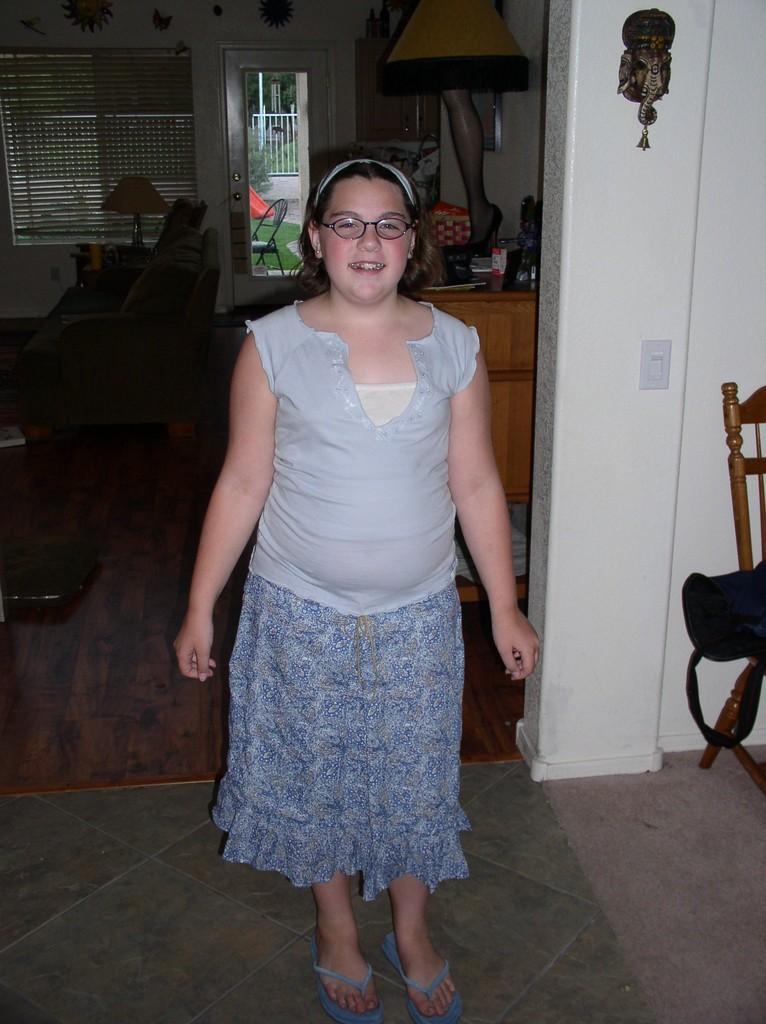In one or two sentences, can you explain what this image depicts? in the picture a woman is standing and laughing there is a room in the room there are many items such as sofa chairs mirror lamps and decorative items. 